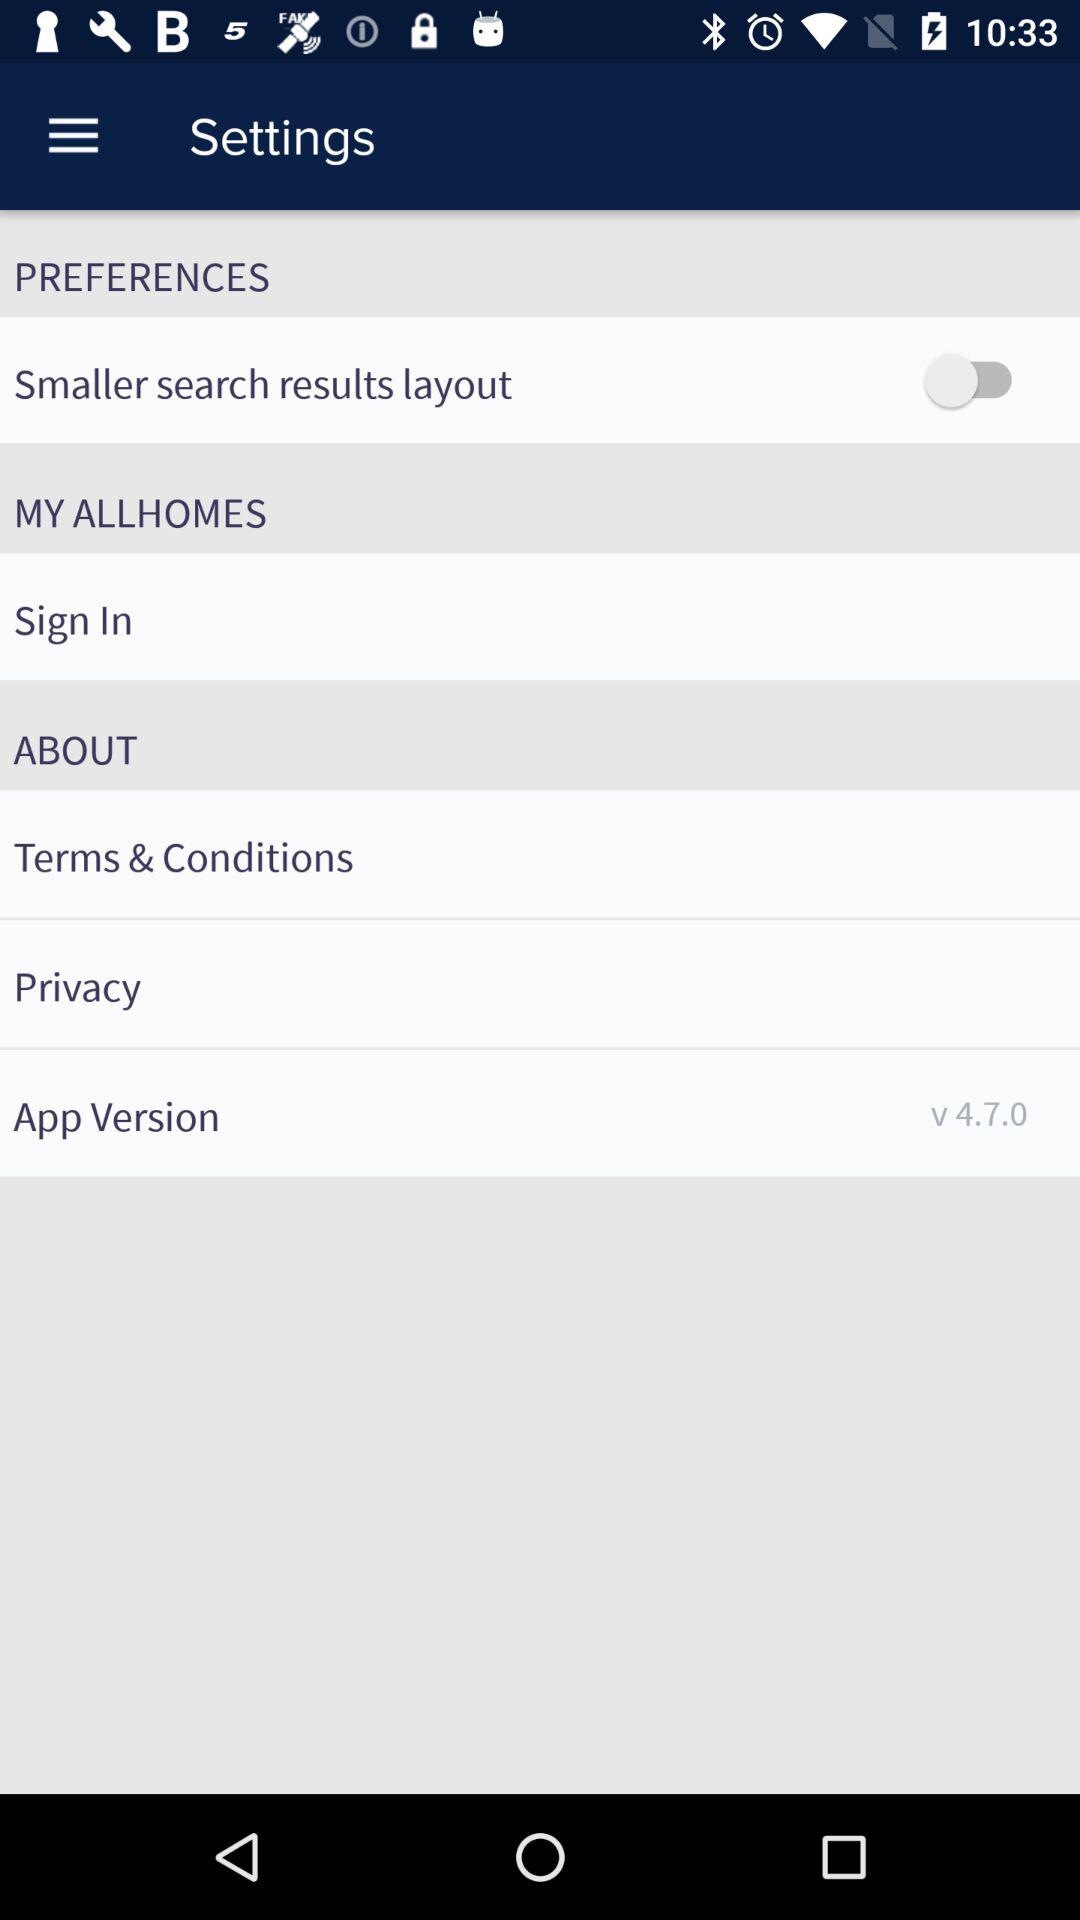What is the status of the setting?
When the provided information is insufficient, respond with <no answer>. <no answer> 